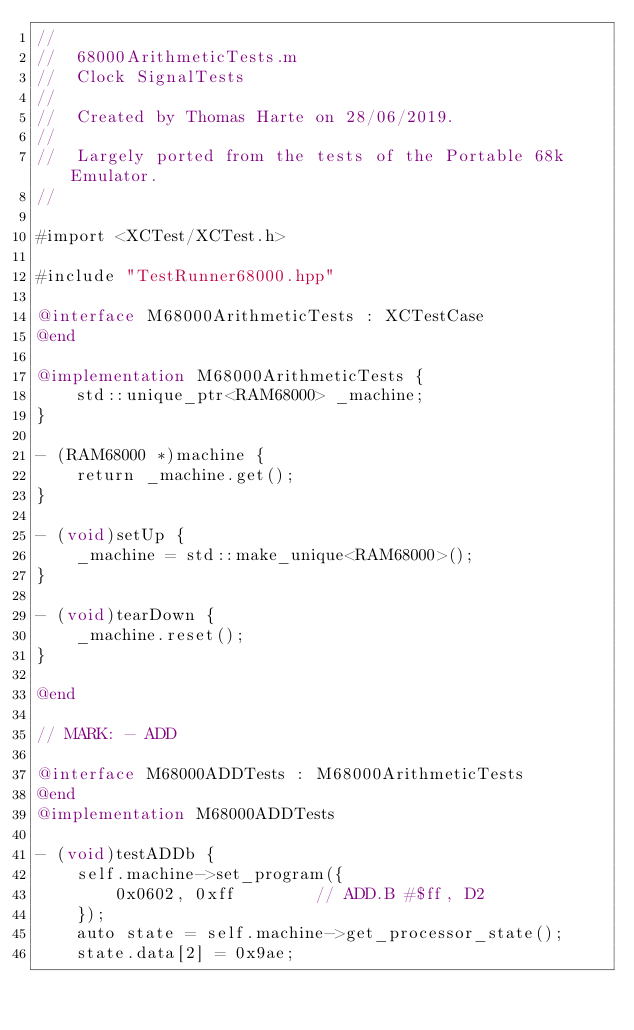Convert code to text. <code><loc_0><loc_0><loc_500><loc_500><_ObjectiveC_>//
//  68000ArithmeticTests.m
//  Clock SignalTests
//
//  Created by Thomas Harte on 28/06/2019.
//
//  Largely ported from the tests of the Portable 68k Emulator.
//

#import <XCTest/XCTest.h>

#include "TestRunner68000.hpp"

@interface M68000ArithmeticTests : XCTestCase
@end

@implementation M68000ArithmeticTests {
	std::unique_ptr<RAM68000> _machine;
}

- (RAM68000 *)machine {
	return _machine.get();
}

- (void)setUp {
	_machine = std::make_unique<RAM68000>();
}

- (void)tearDown {
	_machine.reset();
}

@end

// MARK: - ADD

@interface M68000ADDTests : M68000ArithmeticTests
@end
@implementation M68000ADDTests

- (void)testADDb {
	self.machine->set_program({
		0x0602, 0xff		// ADD.B #$ff, D2
	});
	auto state = self.machine->get_processor_state();
	state.data[2] = 0x9ae;</code> 